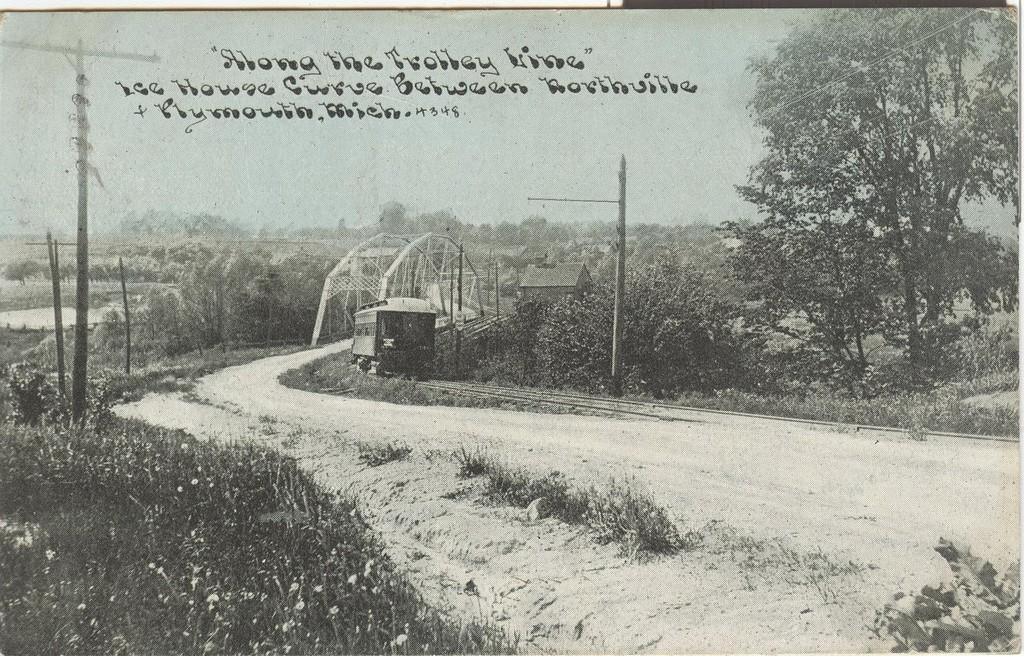In one or two sentences, can you explain what this image depicts? In this picture we can see a black and white photo. We can see a bridge, grass, poles, a vehicle, house, trees and the sky. On the photo, it is written something. 